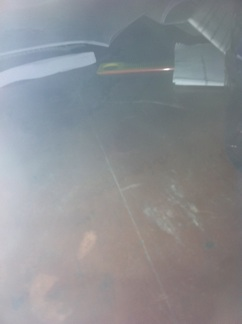Imagine this table is in a mystical library. What kind of book might be on it? In a mystical library, the book on the table might be an ancient tome filled with magical spells and secrets of the universe. What adventures could someone have with the book from the mystical library? With the ancient tome, someone could embark on adventures to find hidden realms, decipher cryptic messages, and unlock powerful spells. The book might guide them through enchanted forests, across treacherous mountains, and into the depths of forgotten dungeons. What if the pen on the table has special powers too? What could those be? The pen on the table could be imbued with special powers, allowing the user to write future events into existence. It could also translate any language, map any location, or even bring illustrations to life. 